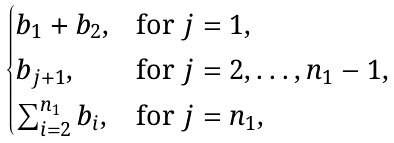<formula> <loc_0><loc_0><loc_500><loc_500>\begin{cases} b _ { 1 } + b _ { 2 } , & \text {for } j = 1 , \\ b _ { j + 1 } , & \text {for } j = 2 , \dots , n _ { 1 } - 1 , \\ \sum _ { i = 2 } ^ { n _ { 1 } } b _ { i } , & \text {for } j = n _ { 1 } , \end{cases}</formula> 